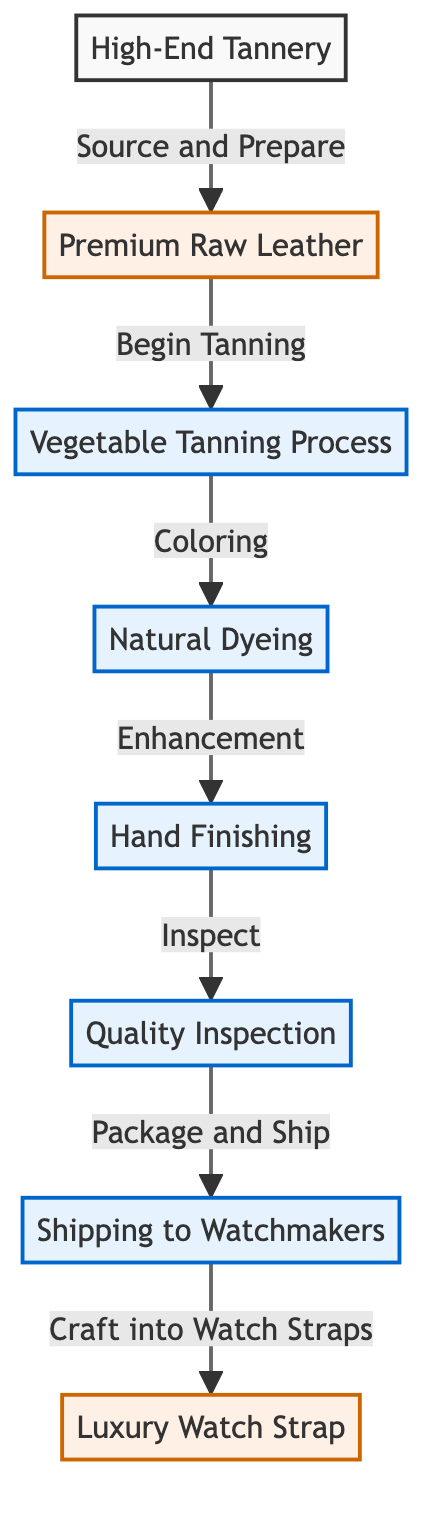What is the first step in the lifecycle of high-quality leather? The first step is the awarding of "Source and Prepare" from the "High-End Tannery" to the "Premium Raw Leather" node.
Answer: Premium Raw Leather How many processes are involved in the tanning of leather? There are four processes involved: Vegetable Tanning Process, Natural Dyeing, Hand Finishing, and Quality Inspection.
Answer: 4 What is the final product in this food chain? The diagram indicates that the final product is the "Luxury Watch Strap."
Answer: Luxury Watch Strap Which process follows the "Natural Dyeing" step? After "Natural Dyeing," the next step is "Hand Finishing."
Answer: Hand Finishing What does the "Quality Inspection" process lead to? The "Quality Inspection" leads to the "Shipping to Watchmakers" process.
Answer: Shipping to Watchmakers In total, how many nodes are present in the diagram? By counting all unique nodes, we find a total of eight nodes represented in the food chain.
Answer: 8 What is the purpose of the "Hand Finishing" process? The "Hand Finishing" process is designated for the enhancement of the leather after dyeing.
Answer: Enhancement Which node is the source of premium raw leather? The source of "Premium Raw Leather" is the "High-End Tannery."
Answer: High-End Tannery What action does the "Shipping to Watchmakers" node represent? The "Shipping to Watchmakers" node represents the action of packaging and sending the product after inspection.
Answer: Package and Ship 